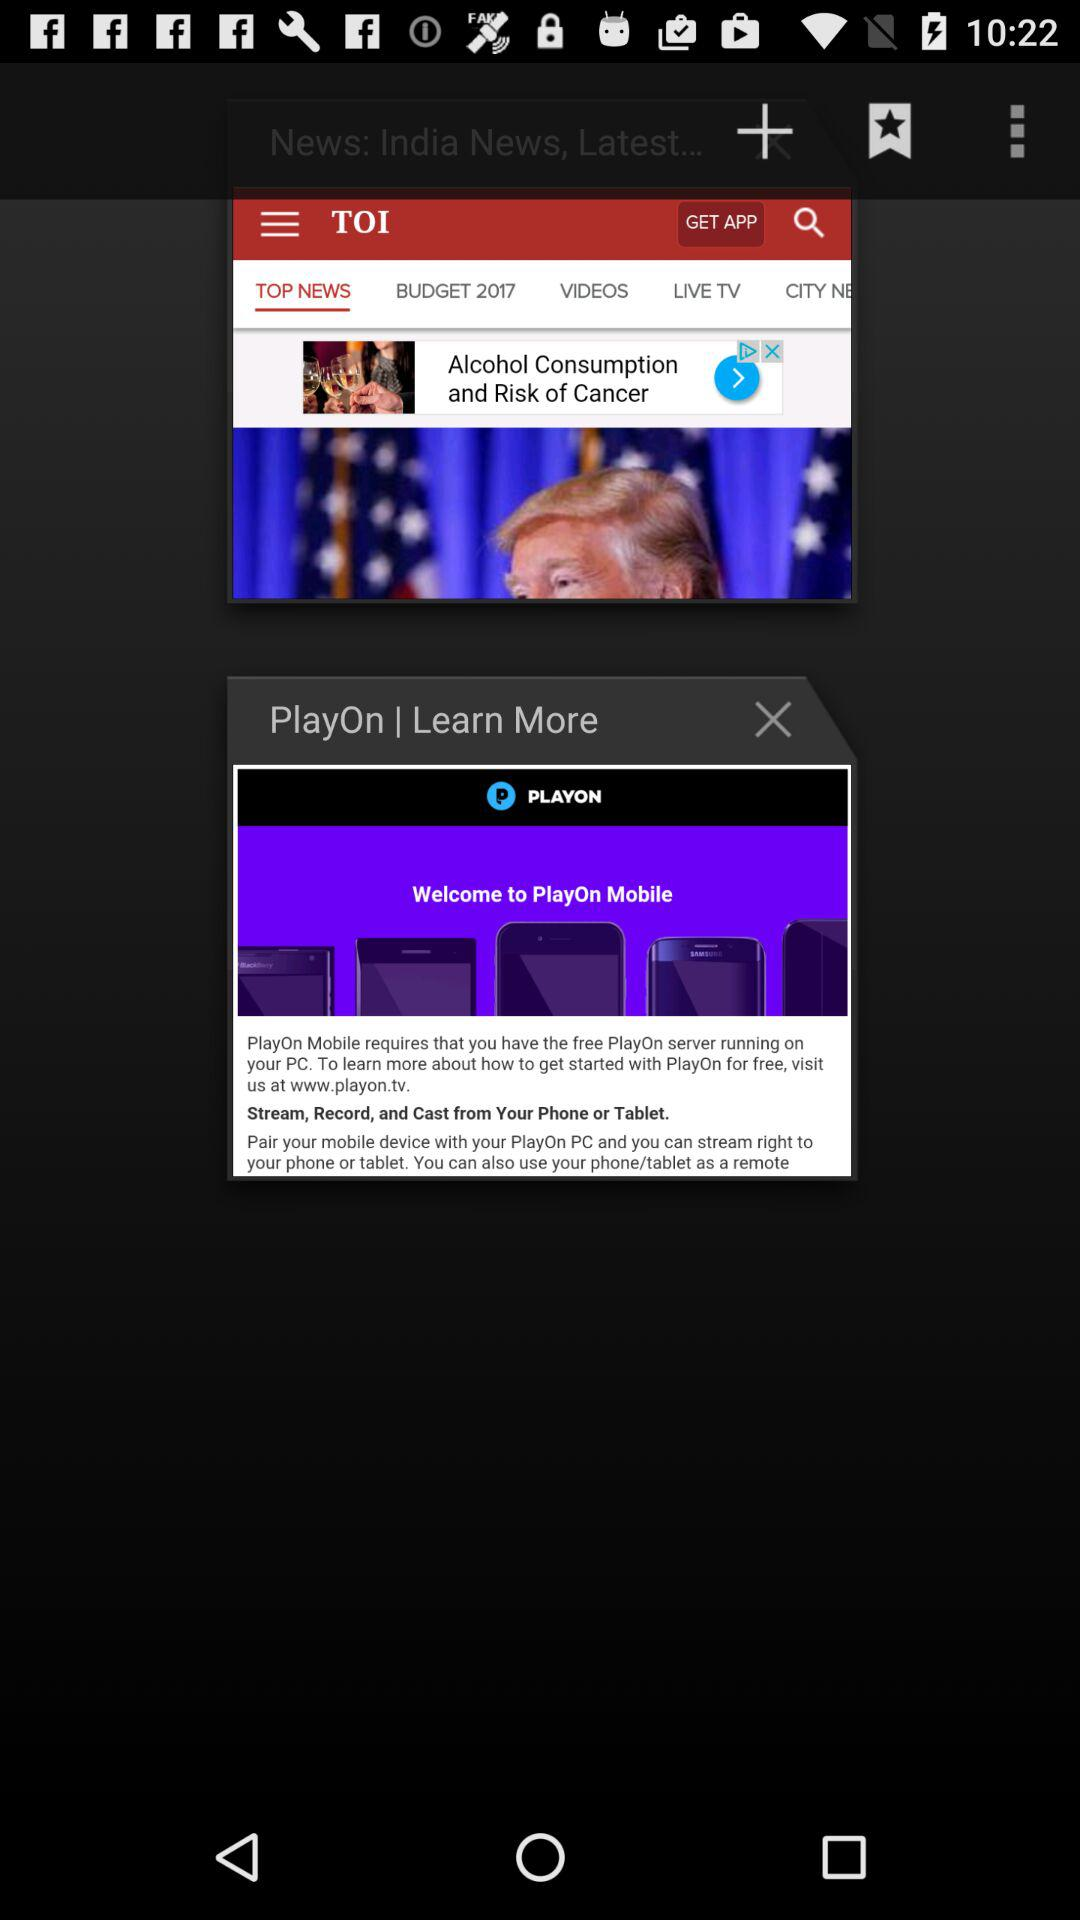Which tab is open in TOI? The open tab is "TOP NEWS". 